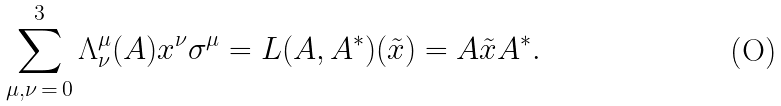<formula> <loc_0><loc_0><loc_500><loc_500>\sum _ { \mu , \nu \, = \, 0 } ^ { 3 } \Lambda _ { \nu } ^ { \mu } ( A ) x ^ { \nu } \sigma ^ { \mu } = L ( A , A ^ { \ast } ) ( \tilde { x } ) = A \tilde { x } A ^ { \ast } .</formula> 